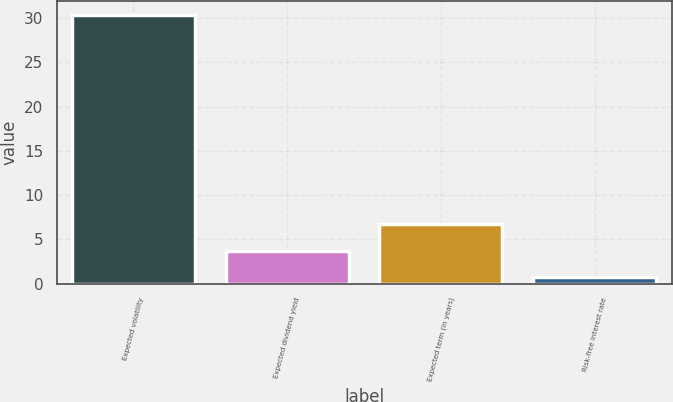<chart> <loc_0><loc_0><loc_500><loc_500><bar_chart><fcel>Expected volatility<fcel>Expected dividend yield<fcel>Expected term (in years)<fcel>Risk-free interest rate<nl><fcel>30.39<fcel>3.73<fcel>6.69<fcel>0.77<nl></chart> 